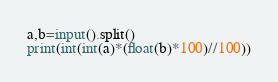<code> <loc_0><loc_0><loc_500><loc_500><_Python_>a,b=input().split()
print(int(int(a)*(float(b)*100)//100))</code> 